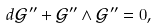<formula> <loc_0><loc_0><loc_500><loc_500>d \mathcal { G } ^ { \prime \prime } + \mathcal { G } ^ { \prime \prime } \wedge \mathcal { G } ^ { \prime \prime } = 0 ,</formula> 